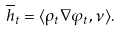<formula> <loc_0><loc_0><loc_500><loc_500>\overline { h } _ { t } = \langle \rho _ { t } \nabla \varphi _ { t } , \nu \rangle .</formula> 